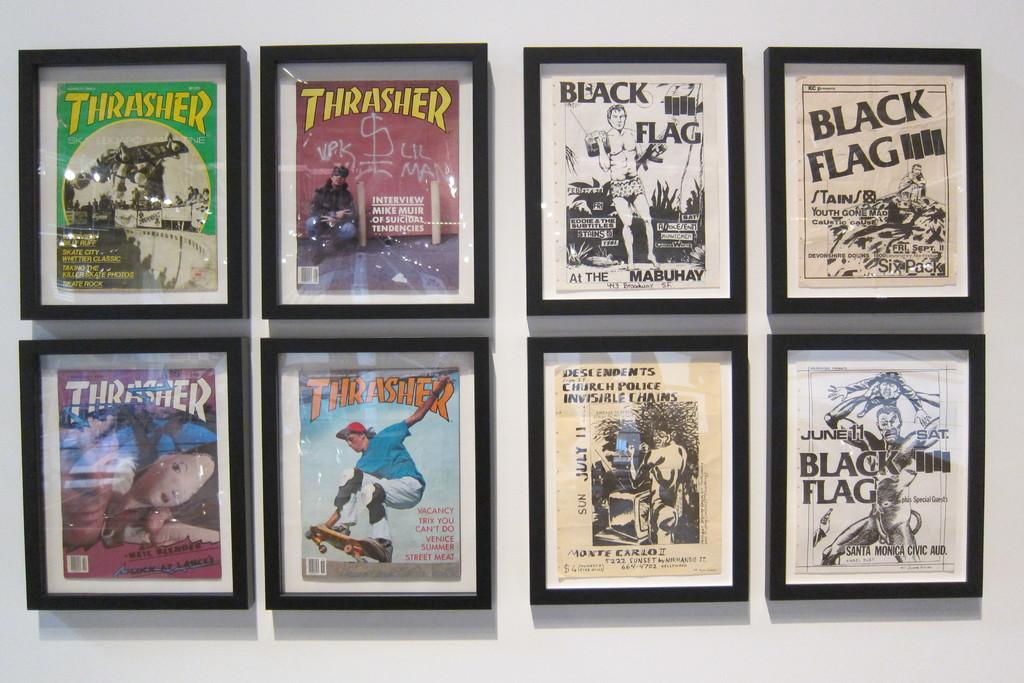Provide a one-sentence caption for the provided image. Framed pictures of Thrasher images and Black Flag images. 